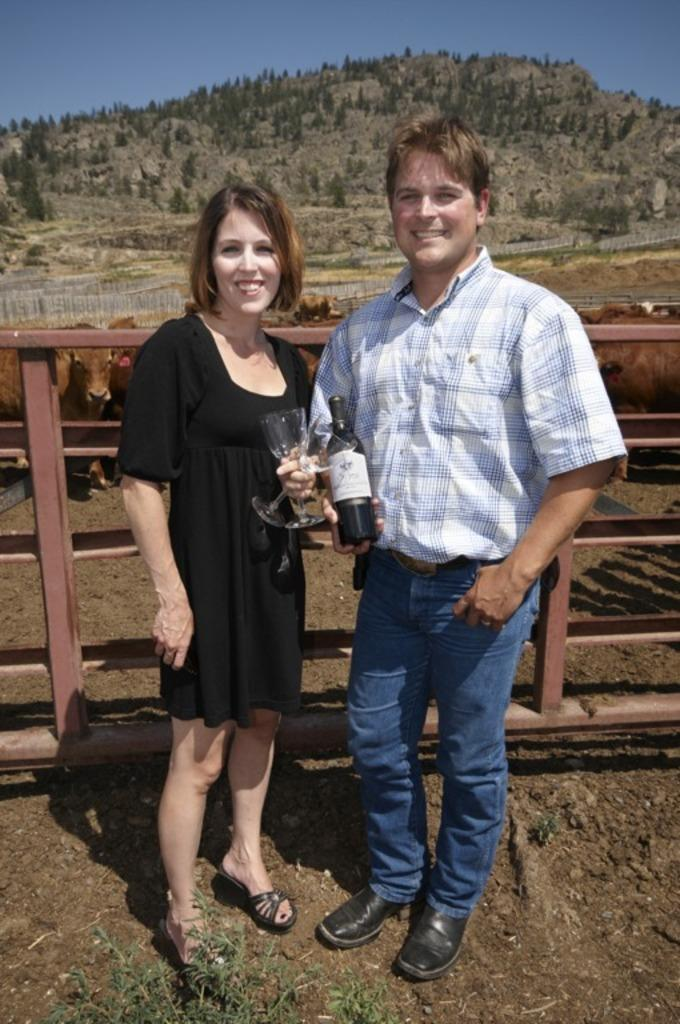How many people are in the image? There is a man and a woman in the image. What are the man and woman standing on? They are standing on a mud floor. What is the man holding in the image? The man is holding a wine bottle and a wine glass. What can be seen in the background of the image? There is a hill in the background of the image, and plants are growing on the hill. What type of blade can be seen in the image? There is no blade present in the image. What is the aftermath of the event depicted in the image? There is no event depicted in the image, so it's not possible to determine the aftermath. 